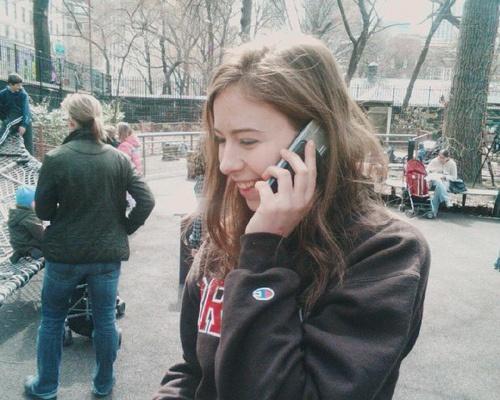Describe the objects in this image and their specific colors. I can see people in lightgray, black, gray, and darkgray tones, people in lightgray, black, blue, gray, and darkblue tones, people in lightgray, darkgray, and gray tones, people in lightgray, teal, black, darkblue, and gray tones, and cell phone in lightgray, gray, black, and darkgray tones in this image. 